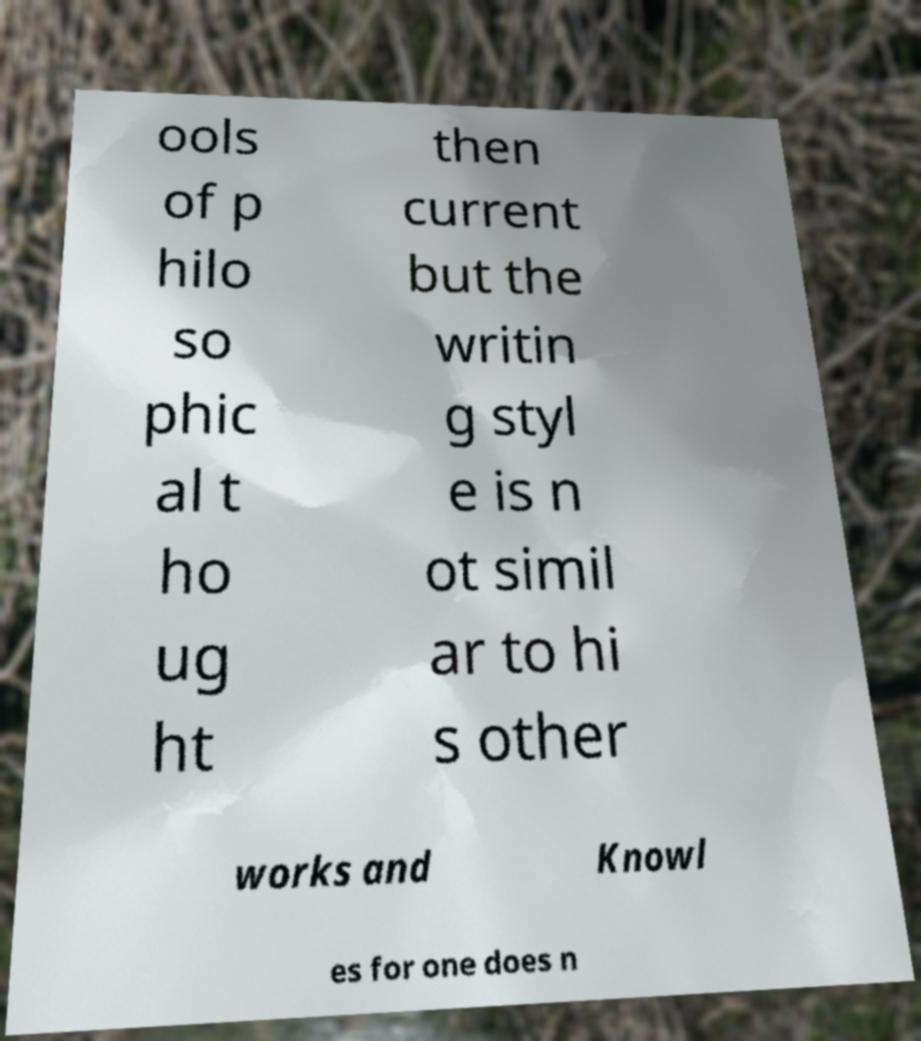Can you accurately transcribe the text from the provided image for me? ools of p hilo so phic al t ho ug ht then current but the writin g styl e is n ot simil ar to hi s other works and Knowl es for one does n 